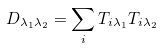<formula> <loc_0><loc_0><loc_500><loc_500>D _ { \lambda _ { 1 } \lambda _ { 2 } } = \sum _ { i } T _ { i \lambda _ { 1 } } T _ { i \lambda _ { 2 } }</formula> 